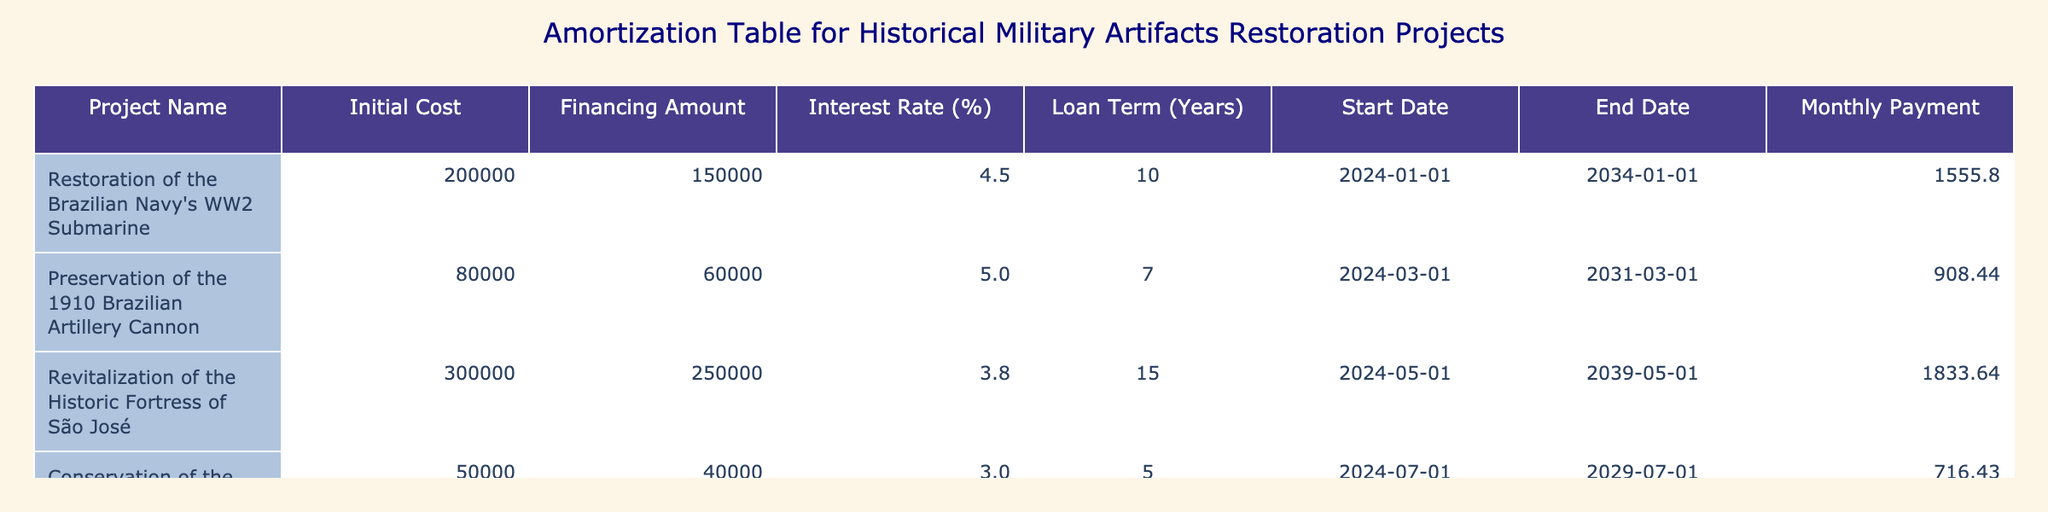What is the total financing amount for the restoration projects listed? To find the total financing amount, I sum the values in the "Financing Amount" column: 150000 + 60000 + 250000 + 40000 + 100000 = 600000.
Answer: 600000 Which project has the highest monthly payment? By comparing the "Monthly Payment" values, I can see that the highest is 1833.64 for the "Revitalization of the Historic Fortress of São José."
Answer: Revitalization of the Historic Fortress of São José Is the interest rate for the "Conservation of the 18th Century Musket Collection" lower than 4%? The interest rate for this project is 3.0, which is indeed lower than 4%.
Answer: Yes What will be the total cost of the "Restoration of the Brazilian Navy's WW2 Submarine" at the end of the loan term? The total cost can be calculated by adding the initial cost to the total payments made over the loan term. The total payments are monthly payments times the number of months: 1555.80 * 120 = 186696. Therefore, the total cost is 200000 + 186696 = 386696.
Answer: 386696 What is the average interest rate for all the projects? To find the average interest rate, I add the interest rates: 4.5 + 5.0 + 3.8 + 3.0 + 4.0 = 20.3, then divide by the number of projects (5): 20.3 / 5 = 4.06.
Answer: 4.06 Which project has the lowest initial cost? By examining the "Initial Cost" column, the lowest value is 50000 for the "Conservation of the 18th Century Musket Collection."
Answer: Conservation of the 18th Century Musket Collection How many projects have a loan term greater than 10 years? I check the "Loan Term (Years)" column and find that two projects, "Revitalization of the Historic Fortress of São José" and "Restoration of the Brazilian Navy's WW2 Submarine," have a loan term greater than 10 years.
Answer: 2 What is the total initial cost of all projects combined? Summing up the "Initial Cost" values gives: 200000 + 80000 + 300000 + 50000 + 120000 = 650000.
Answer: 650000 